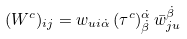<formula> <loc_0><loc_0><loc_500><loc_500>( W ^ { c } ) _ { i j } = w _ { u i \dot { \alpha } } \, ( \tau ^ { c } ) ^ { \dot { \alpha } } _ { \dot { \beta } } \, \bar { w } ^ { \dot { \beta } } _ { j u }</formula> 